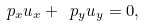Convert formula to latex. <formula><loc_0><loc_0><loc_500><loc_500>\ p _ { x } u _ { x } + \ p _ { y } u _ { y } = 0 ,</formula> 